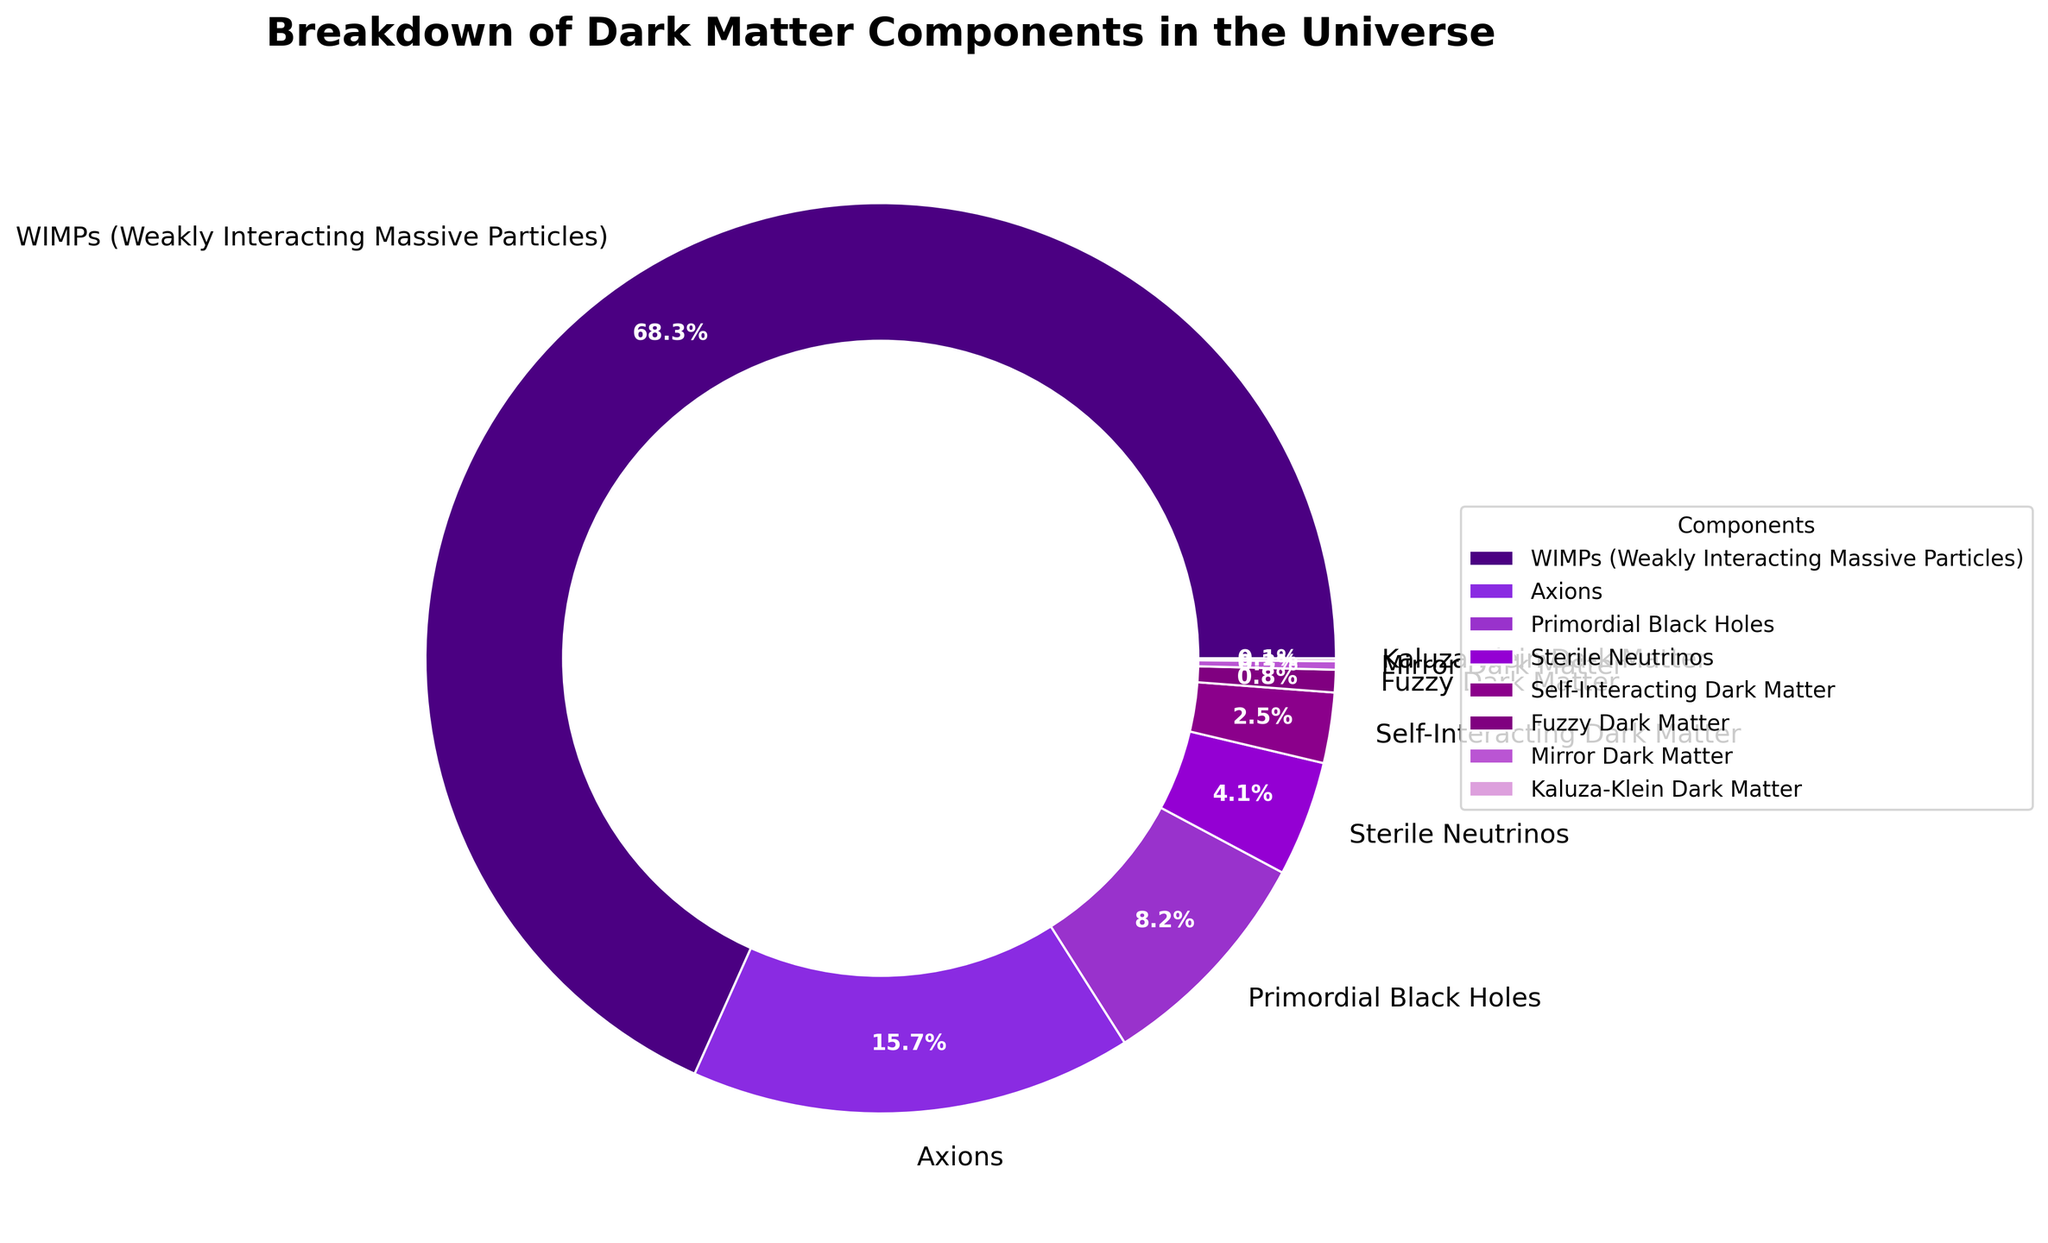Which component has the largest percentage in the breakdown of dark matter? By inspecting the pie chart, the component with the largest wedge is WIMPs (Weakly Interacting Massive Particles).
Answer: WIMPs (Weakly Interacting Massive Particles) Which dark matter component has the smallest percentage, and what is its value? Looking at the smallest wedge on the pie chart, Kaluza-Klein Dark Matter has the smallest percentage.
Answer: Kaluza-Klein Dark Matter, 0.1% How do the percentages of Axions and Primordial Black Holes compare? Axions have a larger percentage than Primordial Black Holes, as represented by their larger wedge in the pie chart.
Answer: Axions > Primordial Black Holes What is the total percentage of Primordial Black Holes, Sterile Neutrinos, and Self-Interacting Dark Matter combined? Add their percentages: 8.2% (Primordial Black Holes) + 4.1% (Sterile Neutrinos) + 2.5% (Self-Interacting Dark Matter) = 14.8%
Answer: 14.8% Which two dark matter components have percentages closest to each other? By comparing the wedges' sizes, Sterile Neutrinos (4.1%) and Self-Interacting Dark Matter (2.5%) have the closest percentages.
Answer: Sterile Neutrinos and Self-Interacting Dark Matter If you combine the percentages of WIMPs and Axions, what fraction of the total dark matter do they represent? Sum the percentages: 68.3% (WIMPs) + 15.7% (Axions) = 84.0%, which represents 0.84 of the total.
Answer: 0.84 Between Fuzzy Dark Matter and Mirror Dark Matter, which one has a higher percentage and by how much? Fuzzy Dark Matter has a higher percentage. Subtract Mirror Dark Matter's percentage from Fuzzy Dark Matter's: 0.8% - 0.3% = 0.5%.
Answer: Fuzzy Dark Matter, by 0.5% Arrange the top three components in descending order of their percentage. Inspecting the largest wedges, WIMPs (68.3%), Axions (15.7%), and Primordial Black Holes (8.2%).
Answer: WIMPs, Axions, Primordial Black Holes What is the mean percentage of the components that are not the dominant WIMPs? Sum percentages excluding WIMPs and divide by the number of remaining components: (15.7 + 8.2 + 4.1 + 2.5 + 0.8 + 0.3 + 0.1) / 7 = 31.7 / 7 ≈ 4.53%.
Answer: 4.53% 